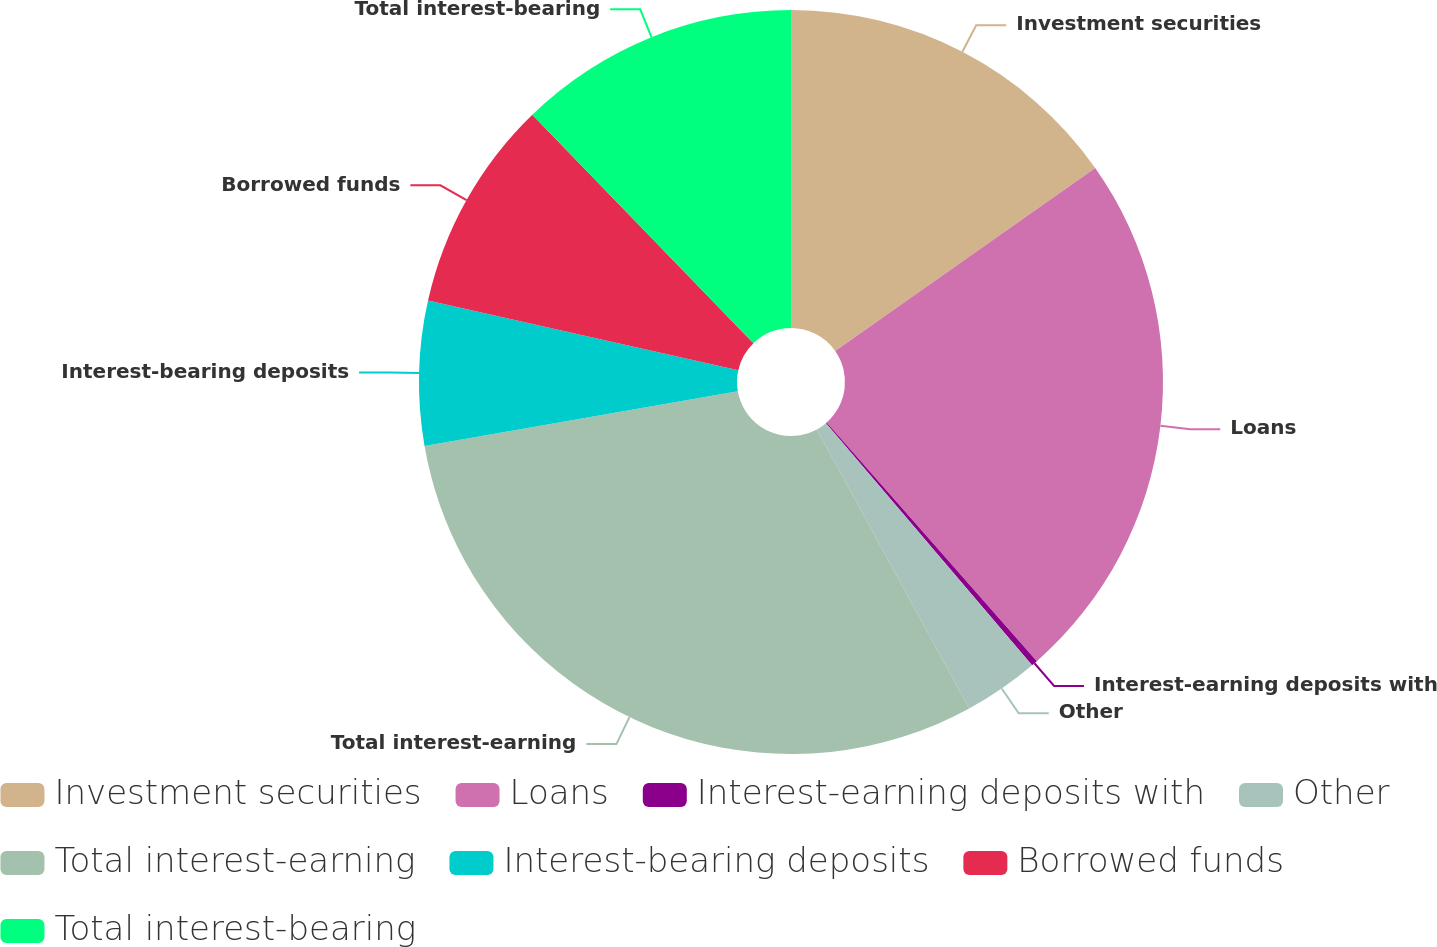Convert chart to OTSL. <chart><loc_0><loc_0><loc_500><loc_500><pie_chart><fcel>Investment securities<fcel>Loans<fcel>Interest-earning deposits with<fcel>Other<fcel>Total interest-earning<fcel>Interest-bearing deposits<fcel>Borrowed funds<fcel>Total interest-bearing<nl><fcel>15.24%<fcel>23.27%<fcel>0.27%<fcel>3.27%<fcel>30.2%<fcel>6.26%<fcel>9.25%<fcel>12.24%<nl></chart> 